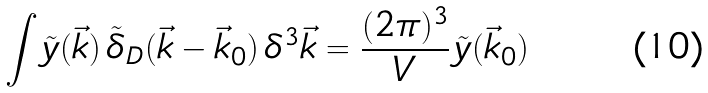<formula> <loc_0><loc_0><loc_500><loc_500>\int \tilde { y } ( \vec { k } ) \, \tilde { \delta } _ { D } ( \vec { k } - \vec { k } _ { 0 } ) \, \delta ^ { 3 } \vec { k } = \frac { ( 2 \pi ) ^ { 3 } } { V } \, \tilde { y } ( \vec { k } _ { 0 } )</formula> 